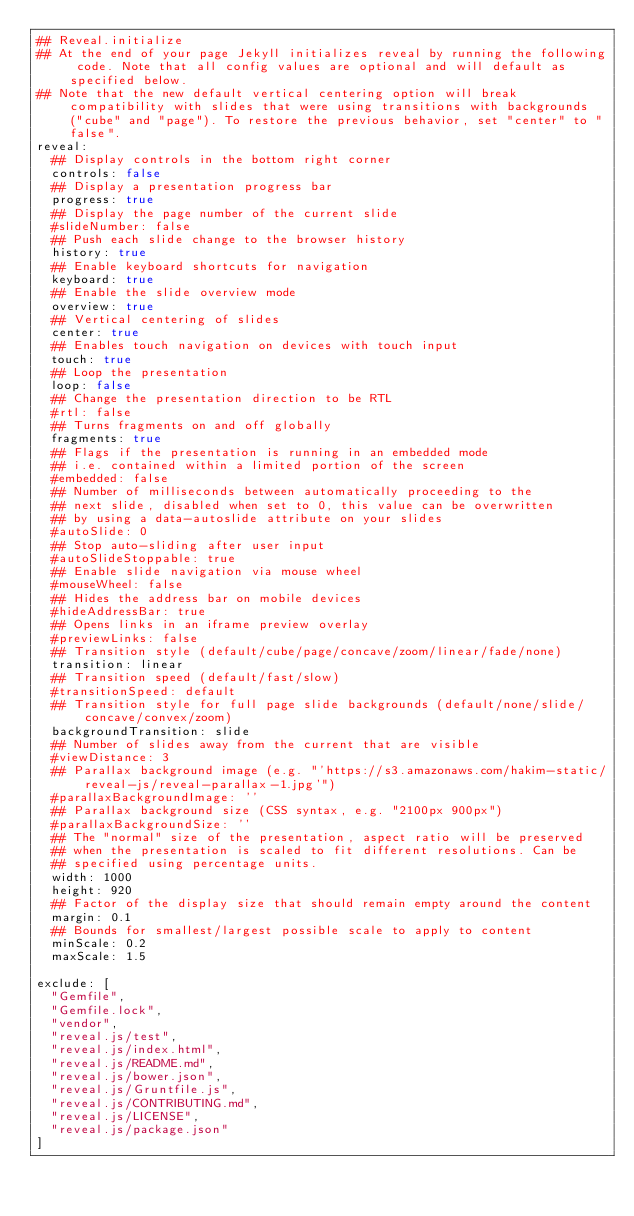<code> <loc_0><loc_0><loc_500><loc_500><_YAML_>## Reveal.initialize
## At the end of your page Jekyll initializes reveal by running the following code. Note that all config values are optional and will default as specified below.
## Note that the new default vertical centering option will break compatibility with slides that were using transitions with backgrounds ("cube" and "page"). To restore the previous behavior, set "center" to "false".
reveal:
  ## Display controls in the bottom right corner
  controls: false
  ## Display a presentation progress bar
  progress: true
  ## Display the page number of the current slide
  #slideNumber: false
  ## Push each slide change to the browser history
  history: true
  ## Enable keyboard shortcuts for navigation
  keyboard: true
  ## Enable the slide overview mode
  overview: true
  ## Vertical centering of slides
  center: true
  ## Enables touch navigation on devices with touch input
  touch: true
  ## Loop the presentation
  loop: false
  ## Change the presentation direction to be RTL
  #rtl: false
  ## Turns fragments on and off globally
  fragments: true
  ## Flags if the presentation is running in an embedded mode
  ## i.e. contained within a limited portion of the screen
  #embedded: false
  ## Number of milliseconds between automatically proceeding to the
  ## next slide, disabled when set to 0, this value can be overwritten
  ## by using a data-autoslide attribute on your slides
  #autoSlide: 0
  ## Stop auto-sliding after user input
  #autoSlideStoppable: true
  ## Enable slide navigation via mouse wheel
  #mouseWheel: false
  ## Hides the address bar on mobile devices
  #hideAddressBar: true
  ## Opens links in an iframe preview overlay
  #previewLinks: false
  ## Transition style (default/cube/page/concave/zoom/linear/fade/none)
  transition: linear
  ## Transition speed (default/fast/slow)
  #transitionSpeed: default
  ## Transition style for full page slide backgrounds (default/none/slide/concave/convex/zoom)
  backgroundTransition: slide
  ## Number of slides away from the current that are visible
  #viewDistance: 3
  ## Parallax background image (e.g. "'https://s3.amazonaws.com/hakim-static/reveal-js/reveal-parallax-1.jpg'")
  #parallaxBackgroundImage: ''
  ## Parallax background size (CSS syntax, e.g. "2100px 900px")
  #parallaxBackgroundSize: ''
  ## The "normal" size of the presentation, aspect ratio will be preserved
  ## when the presentation is scaled to fit different resolutions. Can be
  ## specified using percentage units.
  width: 1000
  height: 920
  ## Factor of the display size that should remain empty around the content
  margin: 0.1
  ## Bounds for smallest/largest possible scale to apply to content
  minScale: 0.2
  maxScale: 1.5

exclude: [
  "Gemfile",
  "Gemfile.lock",
  "vendor",
  "reveal.js/test",
  "reveal.js/index.html",
  "reveal.js/README.md",
  "reveal.js/bower.json",
  "reveal.js/Gruntfile.js",
  "reveal.js/CONTRIBUTING.md",
  "reveal.js/LICENSE",
  "reveal.js/package.json"
]
</code> 